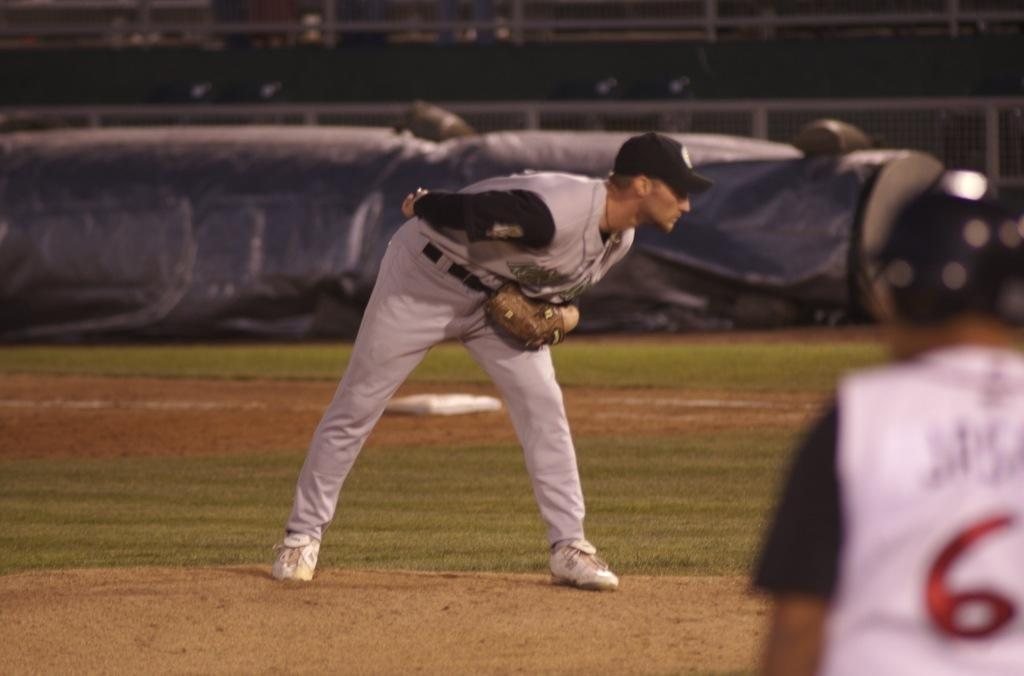<image>
Share a concise interpretation of the image provided. The baseball pitcher is on the mound and player number 6 looks on. 